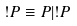<formula> <loc_0><loc_0><loc_500><loc_500>! P \equiv P | ! P</formula> 